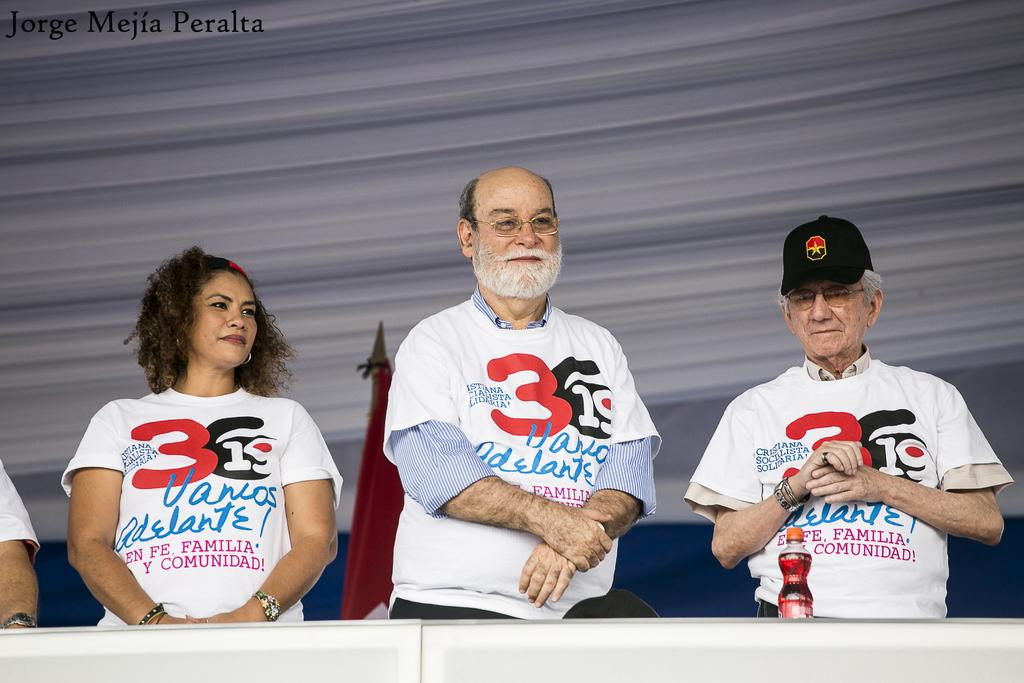Provide a one-sentence caption for the provided image. Jorge Mejia Peralta took a photograph of three people wearing white shirts. 